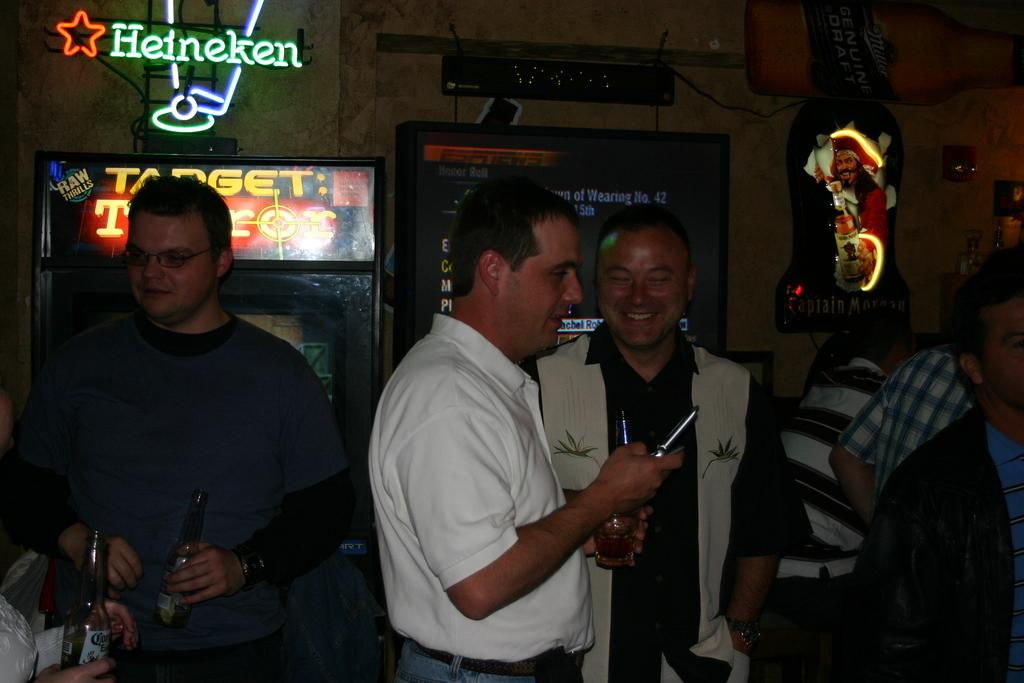Who or what is present in the image? There are people in the image. What are the people doing in the image? The people are standing in the image. What objects are the people holding in their hands? The people are holding wine bottles in their hands. What can be seen in the background of the image? There is a TV screen in the background of the image. What type of line or chain is visible on the canvas in the image? There is no canvas or line/chain present in the image. 